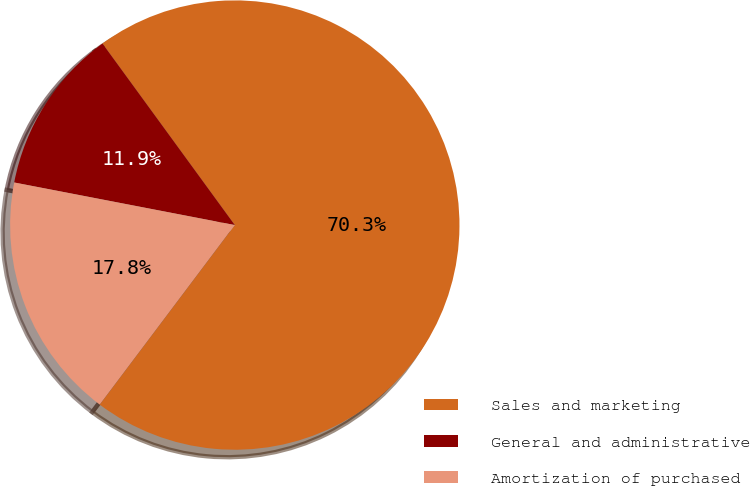<chart> <loc_0><loc_0><loc_500><loc_500><pie_chart><fcel>Sales and marketing<fcel>General and administrative<fcel>Amortization of purchased<nl><fcel>70.29%<fcel>11.94%<fcel>17.77%<nl></chart> 